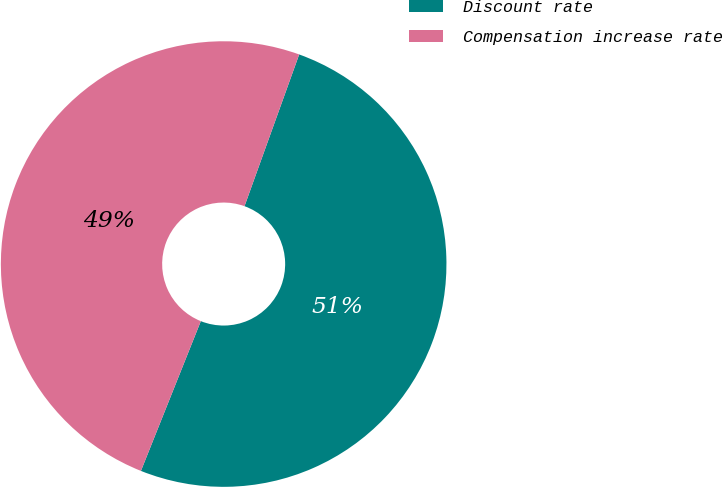Convert chart. <chart><loc_0><loc_0><loc_500><loc_500><pie_chart><fcel>Discount rate<fcel>Compensation increase rate<nl><fcel>50.55%<fcel>49.45%<nl></chart> 